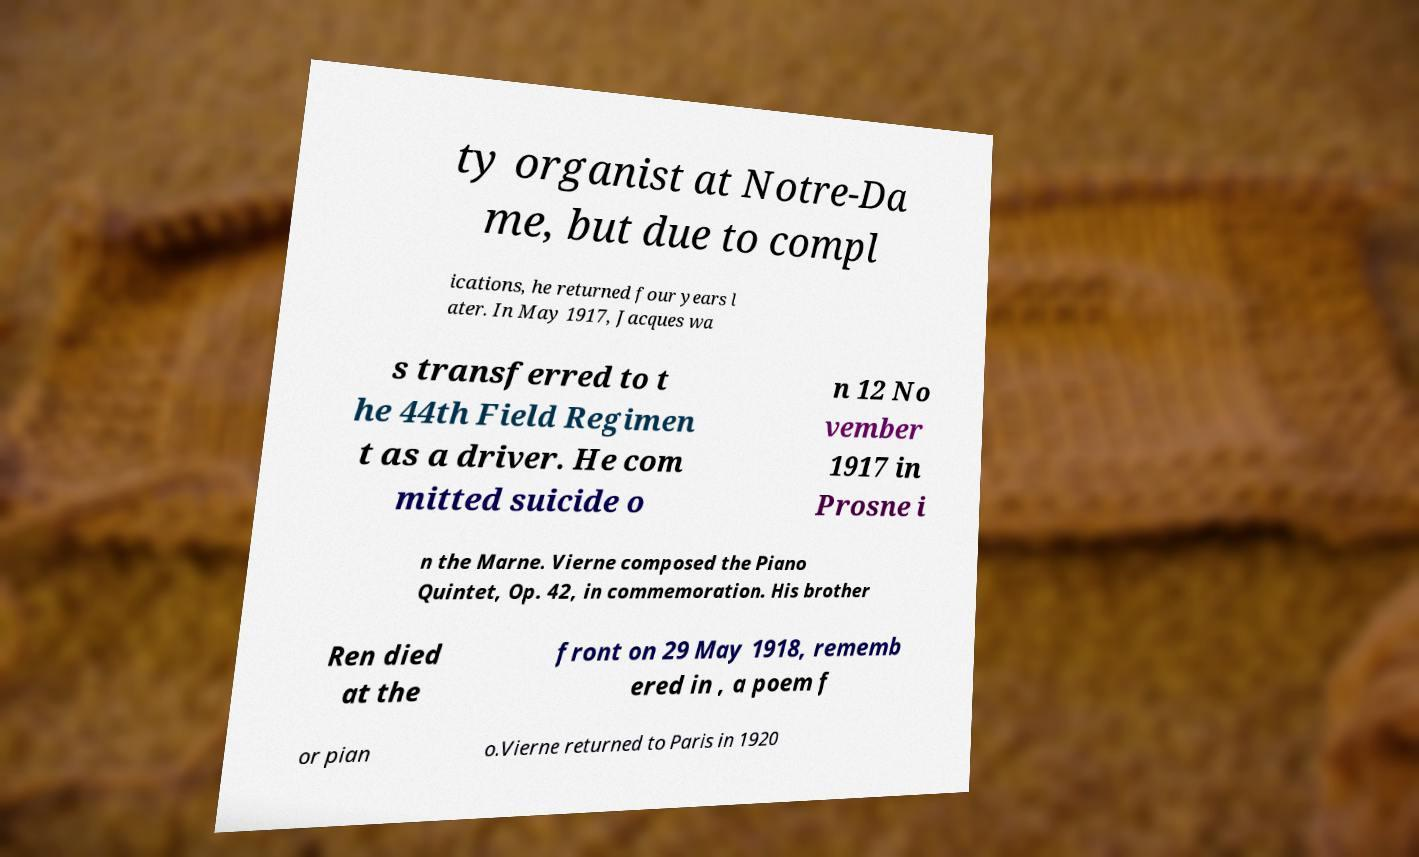For documentation purposes, I need the text within this image transcribed. Could you provide that? ty organist at Notre-Da me, but due to compl ications, he returned four years l ater. In May 1917, Jacques wa s transferred to t he 44th Field Regimen t as a driver. He com mitted suicide o n 12 No vember 1917 in Prosne i n the Marne. Vierne composed the Piano Quintet, Op. 42, in commemoration. His brother Ren died at the front on 29 May 1918, rememb ered in , a poem f or pian o.Vierne returned to Paris in 1920 